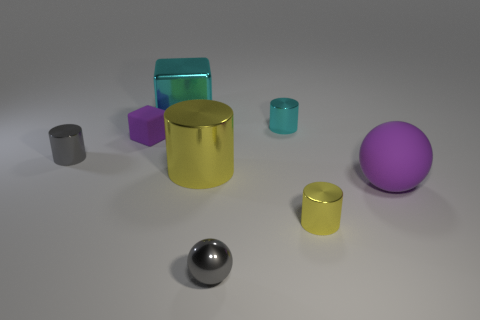Subtract all blue cylinders. Subtract all green spheres. How many cylinders are left? 4 Add 1 blue metal cylinders. How many objects exist? 9 Subtract all balls. How many objects are left? 6 Add 5 small yellow things. How many small yellow things exist? 6 Subtract 0 brown blocks. How many objects are left? 8 Subtract all small gray spheres. Subtract all small matte blocks. How many objects are left? 6 Add 3 yellow shiny cylinders. How many yellow shiny cylinders are left? 5 